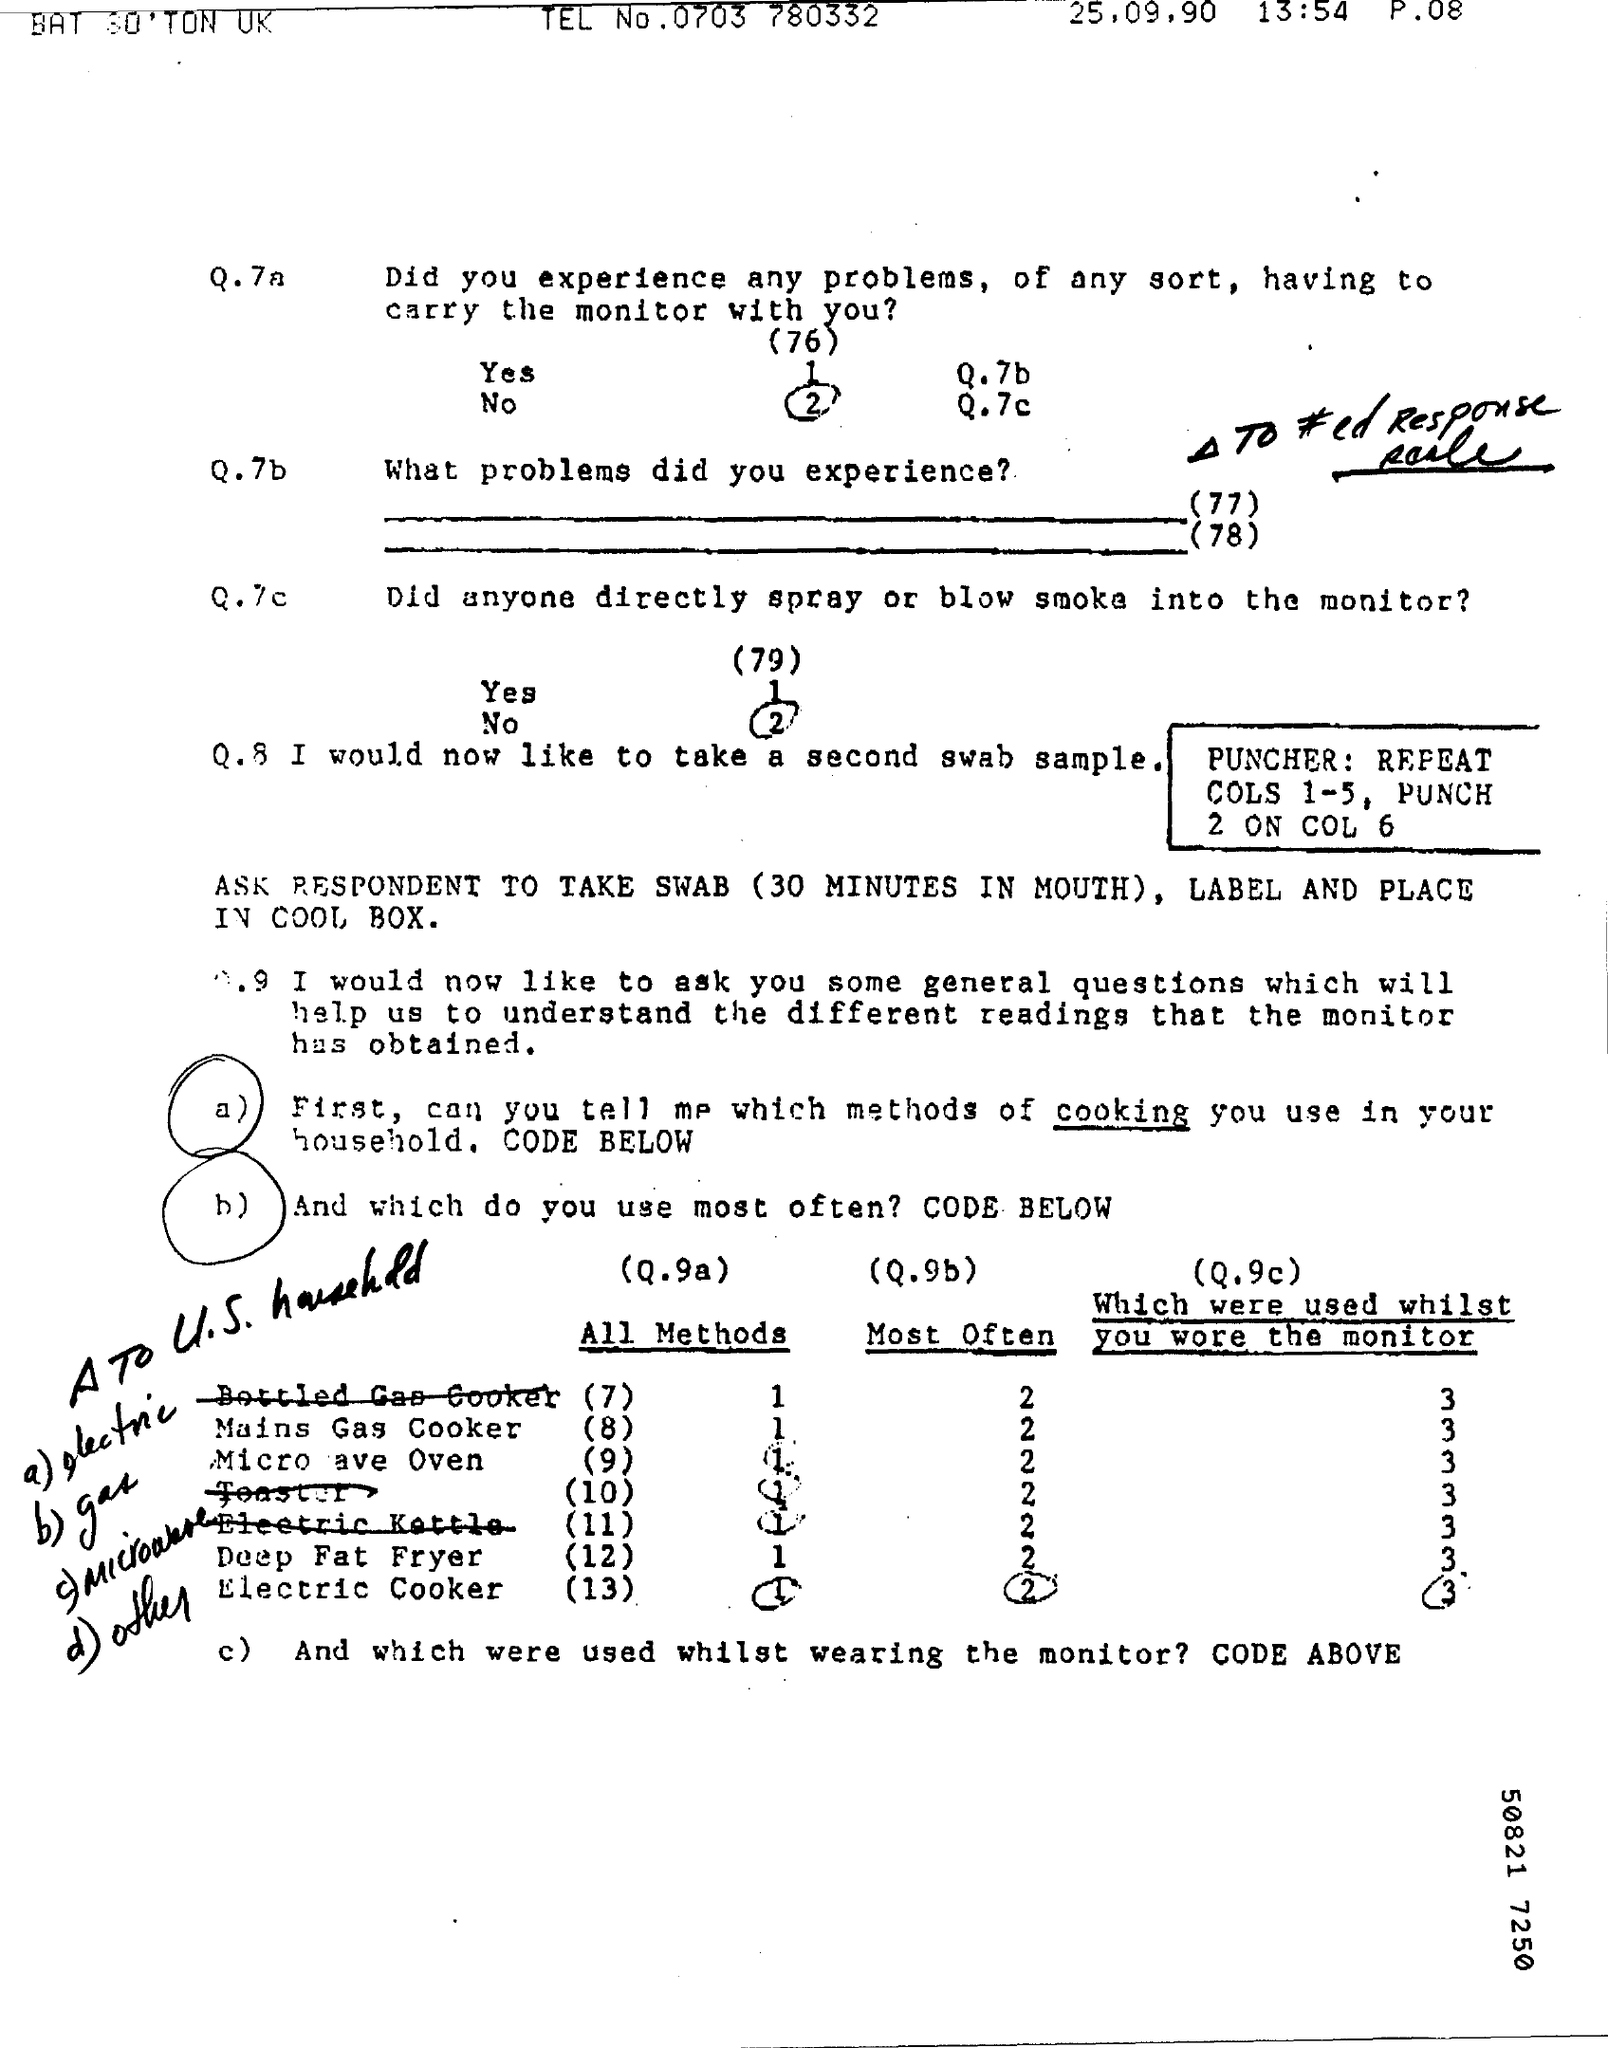Mention a couple of crucial points in this snapshot. The telephone number is 0703 780332.. The date on the document is September 25, 1990. 